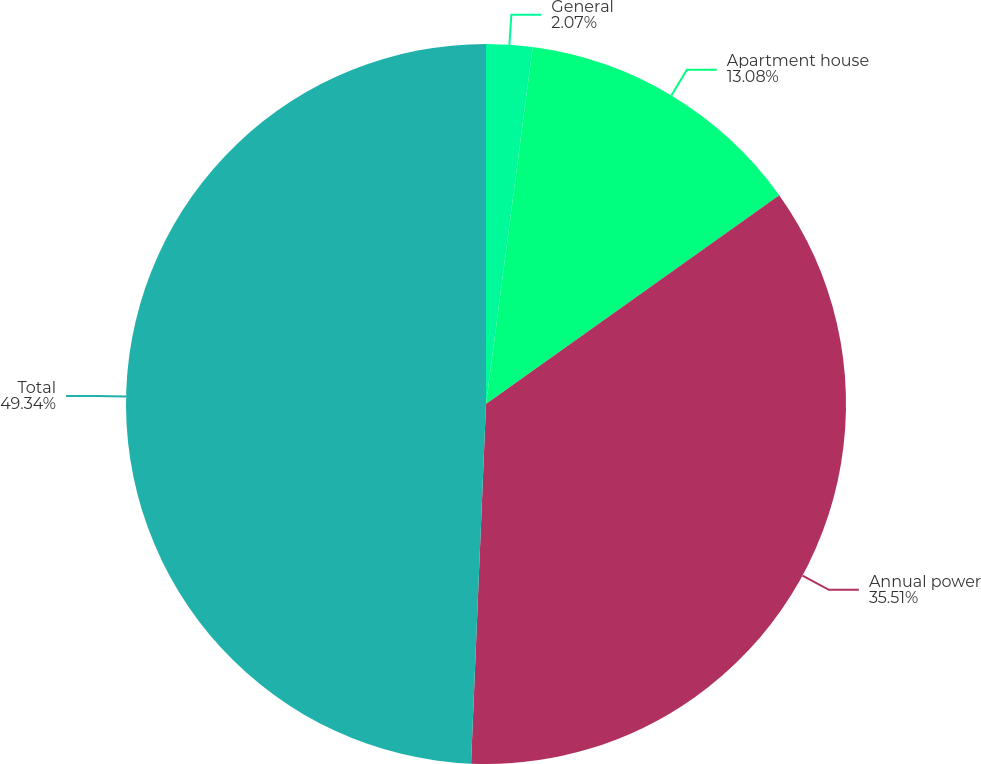Convert chart to OTSL. <chart><loc_0><loc_0><loc_500><loc_500><pie_chart><fcel>General<fcel>Apartment house<fcel>Annual power<fcel>Total<nl><fcel>2.07%<fcel>13.08%<fcel>35.51%<fcel>49.34%<nl></chart> 